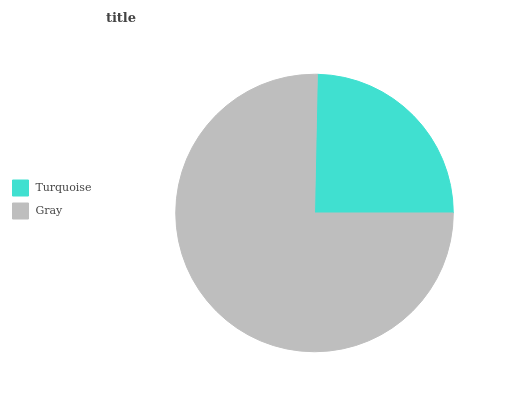Is Turquoise the minimum?
Answer yes or no. Yes. Is Gray the maximum?
Answer yes or no. Yes. Is Gray the minimum?
Answer yes or no. No. Is Gray greater than Turquoise?
Answer yes or no. Yes. Is Turquoise less than Gray?
Answer yes or no. Yes. Is Turquoise greater than Gray?
Answer yes or no. No. Is Gray less than Turquoise?
Answer yes or no. No. Is Gray the high median?
Answer yes or no. Yes. Is Turquoise the low median?
Answer yes or no. Yes. Is Turquoise the high median?
Answer yes or no. No. Is Gray the low median?
Answer yes or no. No. 